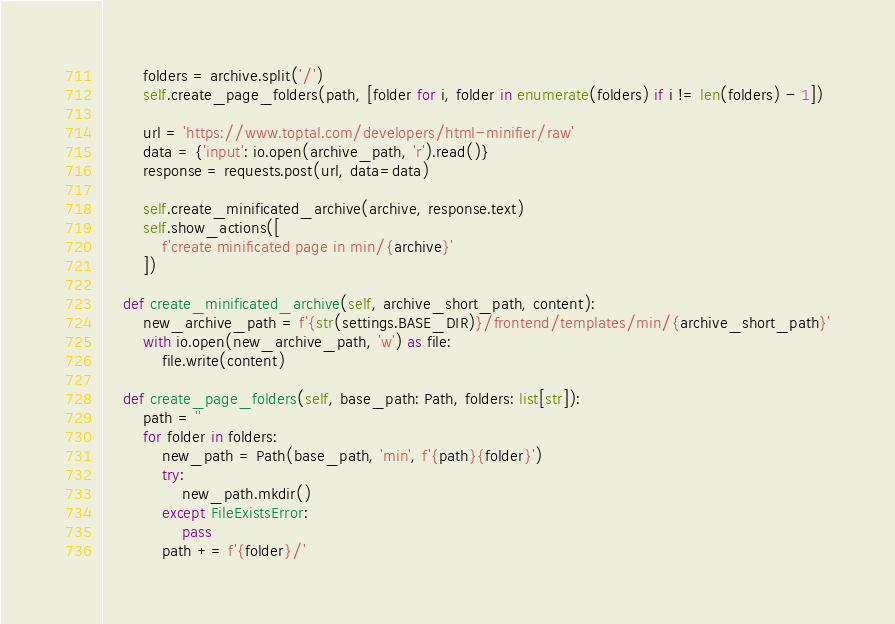<code> <loc_0><loc_0><loc_500><loc_500><_Python_>        folders = archive.split('/')
        self.create_page_folders(path, [folder for i, folder in enumerate(folders) if i != len(folders) - 1])

        url = 'https://www.toptal.com/developers/html-minifier/raw'
        data = {'input': io.open(archive_path, 'r').read()}
        response = requests.post(url, data=data)

        self.create_minificated_archive(archive, response.text)
        self.show_actions([
            f'create minificated page in min/{archive}'
        ])

    def create_minificated_archive(self, archive_short_path, content):
        new_archive_path = f'{str(settings.BASE_DIR)}/frontend/templates/min/{archive_short_path}'
        with io.open(new_archive_path, 'w') as file:
            file.write(content)

    def create_page_folders(self, base_path: Path, folders: list[str]):
        path = ''
        for folder in folders:
            new_path = Path(base_path, 'min', f'{path}{folder}')
            try:
                new_path.mkdir()
            except FileExistsError:
                pass
            path += f'{folder}/'</code> 